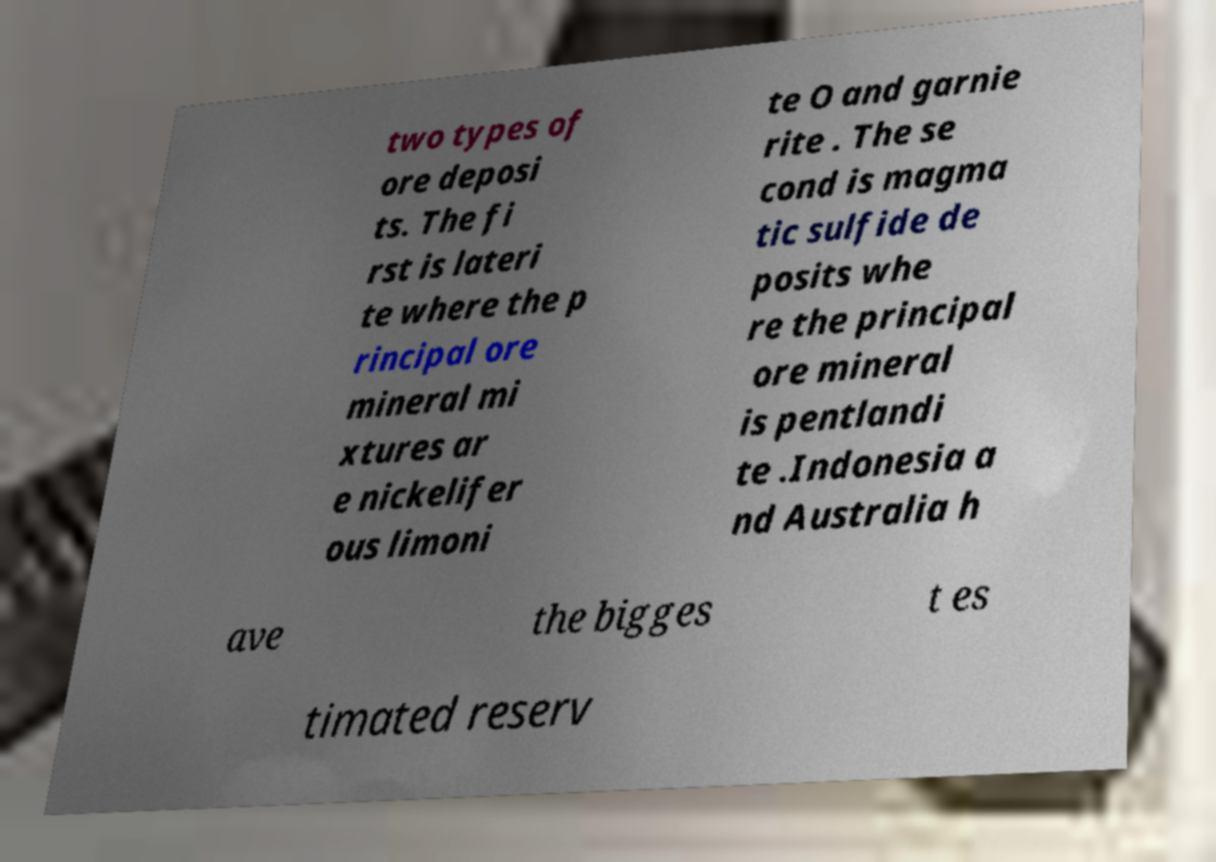Could you extract and type out the text from this image? two types of ore deposi ts. The fi rst is lateri te where the p rincipal ore mineral mi xtures ar e nickelifer ous limoni te O and garnie rite . The se cond is magma tic sulfide de posits whe re the principal ore mineral is pentlandi te .Indonesia a nd Australia h ave the bigges t es timated reserv 